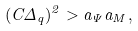<formula> <loc_0><loc_0><loc_500><loc_500>( C \Delta _ { q } ) ^ { 2 } > a _ { \Psi } a _ { M } ,</formula> 